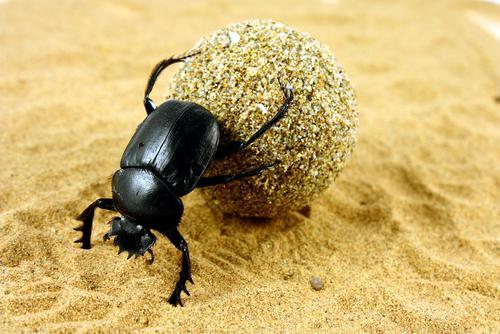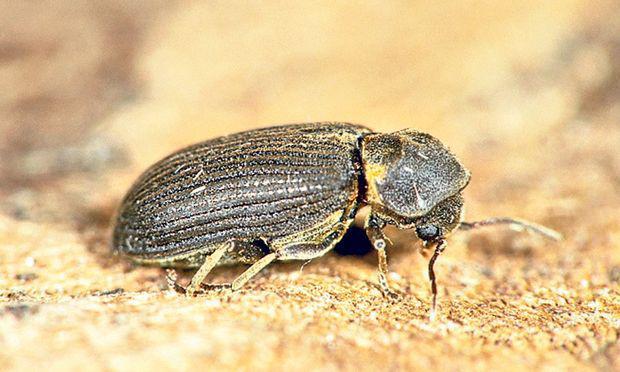The first image is the image on the left, the second image is the image on the right. Given the left and right images, does the statement "There are two bugs in one of the images." hold true? Answer yes or no. No. 